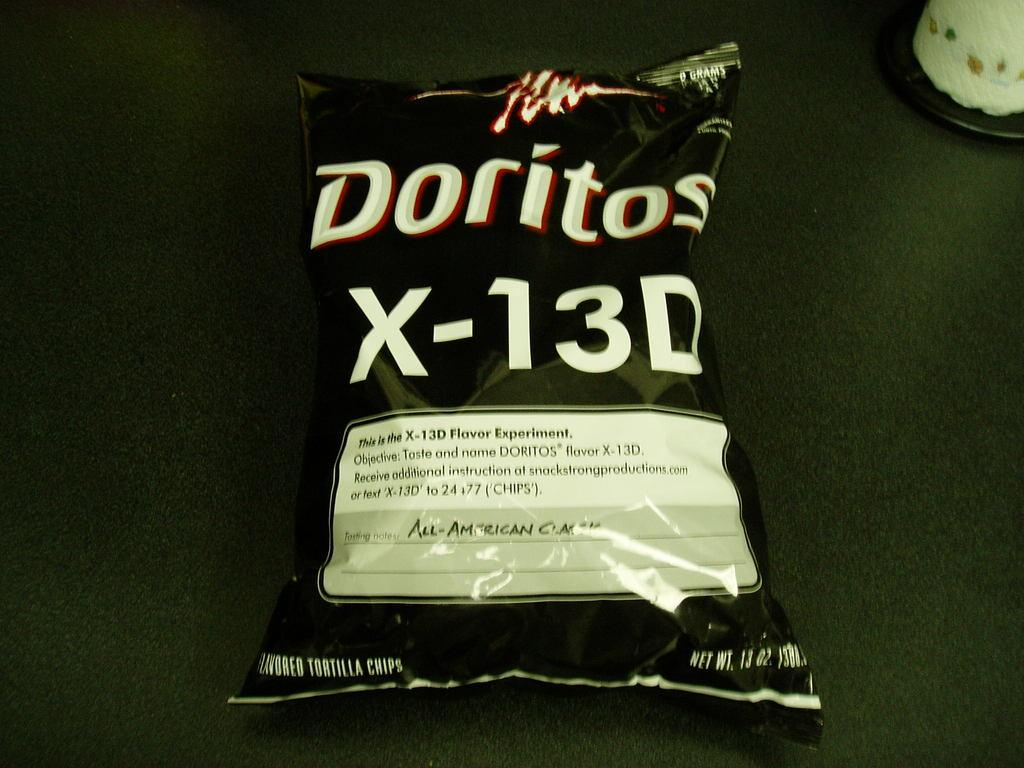<image>
Render a clear and concise summary of the photo. An experimental bag of Doritos labeled x-13D is unopened. 